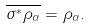<formula> <loc_0><loc_0><loc_500><loc_500>\overline { \sigma ^ { * } \rho _ { \alpha } } = \rho _ { \alpha } .</formula> 